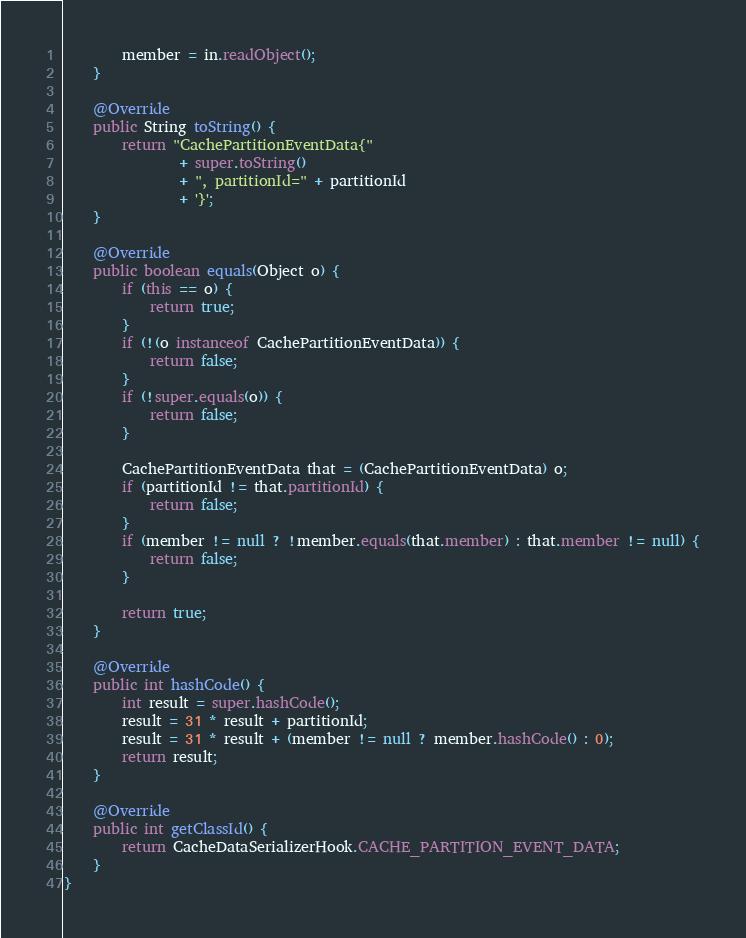Convert code to text. <code><loc_0><loc_0><loc_500><loc_500><_Java_>        member = in.readObject();
    }

    @Override
    public String toString() {
        return "CachePartitionEventData{"
                + super.toString()
                + ", partitionId=" + partitionId
                + '}';
    }

    @Override
    public boolean equals(Object o) {
        if (this == o) {
            return true;
        }
        if (!(o instanceof CachePartitionEventData)) {
            return false;
        }
        if (!super.equals(o)) {
            return false;
        }

        CachePartitionEventData that = (CachePartitionEventData) o;
        if (partitionId != that.partitionId) {
            return false;
        }
        if (member != null ? !member.equals(that.member) : that.member != null) {
            return false;
        }

        return true;
    }

    @Override
    public int hashCode() {
        int result = super.hashCode();
        result = 31 * result + partitionId;
        result = 31 * result + (member != null ? member.hashCode() : 0);
        return result;
    }

    @Override
    public int getClassId() {
        return CacheDataSerializerHook.CACHE_PARTITION_EVENT_DATA;
    }
}
</code> 